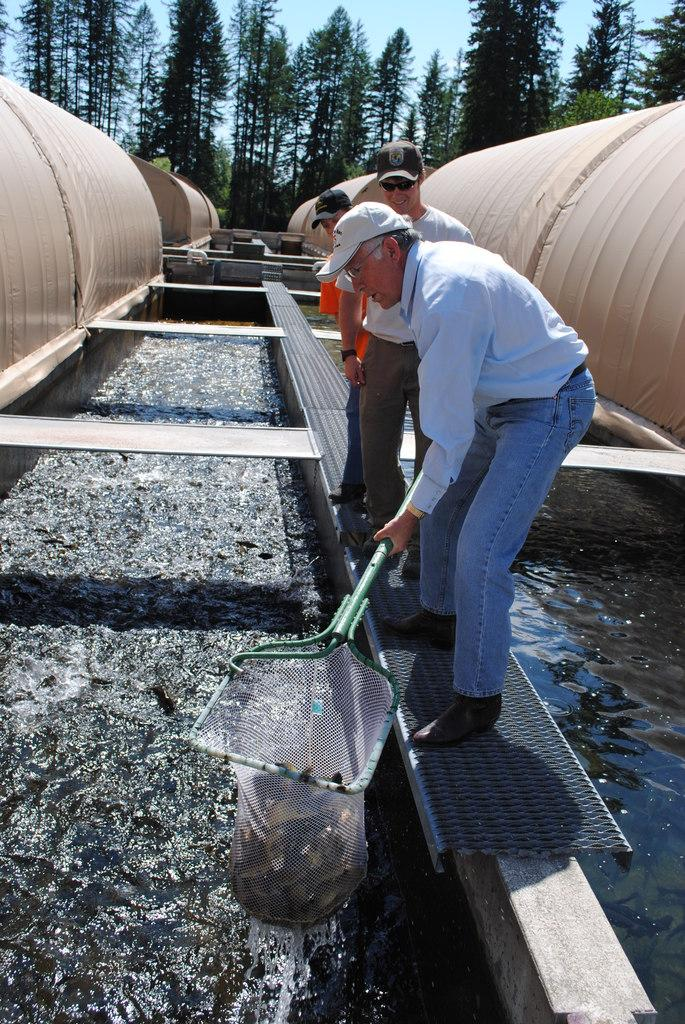What is the main feature in the image? There is a fish pond in the image. Are there any people near the fish pond? Yes, there are three men standing near the fish pond. What are the men doing? One man is catching fish with a net. What can be seen in the background of the image? There are trees in the background of the image. Can you see any volcanoes erupting in the image? No, there are no volcanoes present in the image. Are there any ducks swimming in the fish pond? The image does not show any ducks in the fish pond. 